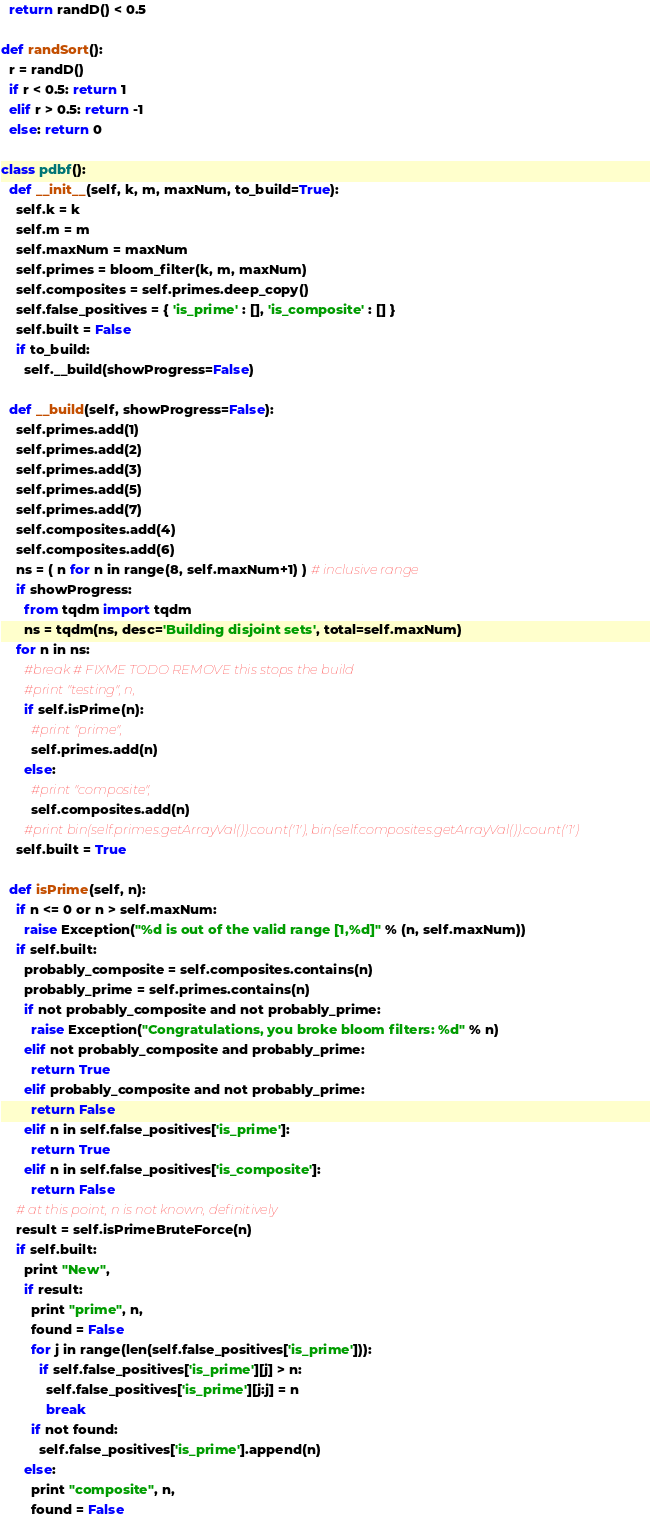<code> <loc_0><loc_0><loc_500><loc_500><_Python_>  return randD() < 0.5

def randSort():
  r = randD()
  if r < 0.5: return 1
  elif r > 0.5: return -1
  else: return 0

class pdbf():
  def __init__(self, k, m, maxNum, to_build=True):
    self.k = k
    self.m = m
    self.maxNum = maxNum
    self.primes = bloom_filter(k, m, maxNum)
    self.composites = self.primes.deep_copy()
    self.false_positives = { 'is_prime' : [], 'is_composite' : [] }
    self.built = False
    if to_build:
      self.__build(showProgress=False)

  def __build(self, showProgress=False):
    self.primes.add(1)
    self.primes.add(2)
    self.primes.add(3)
    self.primes.add(5)
    self.primes.add(7)
    self.composites.add(4)
    self.composites.add(6)
    ns = ( n for n in range(8, self.maxNum+1) ) # inclusive range
    if showProgress:
      from tqdm import tqdm
      ns = tqdm(ns, desc='Building disjoint sets', total=self.maxNum)
    for n in ns:
      #break # FIXME TODO REMOVE this stops the build
      #print "testing", n,
      if self.isPrime(n):
        #print "prime",
        self.primes.add(n)
      else:
        #print "composite",
        self.composites.add(n)
      #print bin(self.primes.getArrayVal()).count('1'), bin(self.composites.getArrayVal()).count('1')
    self.built = True

  def isPrime(self, n):
    if n <= 0 or n > self.maxNum:
      raise Exception("%d is out of the valid range [1,%d]" % (n, self.maxNum))
    if self.built:
      probably_composite = self.composites.contains(n)
      probably_prime = self.primes.contains(n)
      if not probably_composite and not probably_prime:
        raise Exception("Congratulations, you broke bloom filters: %d" % n)
      elif not probably_composite and probably_prime:
        return True
      elif probably_composite and not probably_prime:
        return False
      elif n in self.false_positives['is_prime']:
        return True
      elif n in self.false_positives['is_composite']:
        return False
    # at this point, n is not known, definitively
    result = self.isPrimeBruteForce(n)
    if self.built:
      print "New",
      if result:
        print "prime", n,
        found = False
        for j in range(len(self.false_positives['is_prime'])):
          if self.false_positives['is_prime'][j] > n:
            self.false_positives['is_prime'][j:j] = n
            break
        if not found:
          self.false_positives['is_prime'].append(n)
      else:
        print "composite", n,
        found = False</code> 